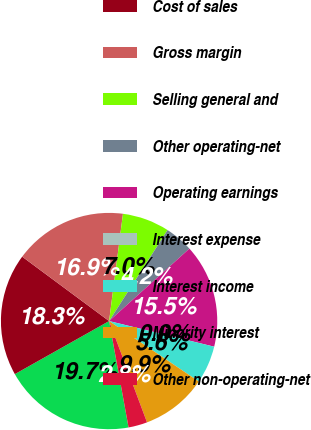<chart> <loc_0><loc_0><loc_500><loc_500><pie_chart><fcel>Net sales<fcel>Cost of sales<fcel>Gross margin<fcel>Selling general and<fcel>Other operating-net<fcel>Operating earnings<fcel>Interest expense<fcel>Interest income<fcel>Minority interest<fcel>Other non-operating-net<nl><fcel>19.72%<fcel>18.31%<fcel>16.9%<fcel>7.04%<fcel>4.23%<fcel>15.49%<fcel>0.0%<fcel>5.63%<fcel>9.86%<fcel>2.82%<nl></chart> 